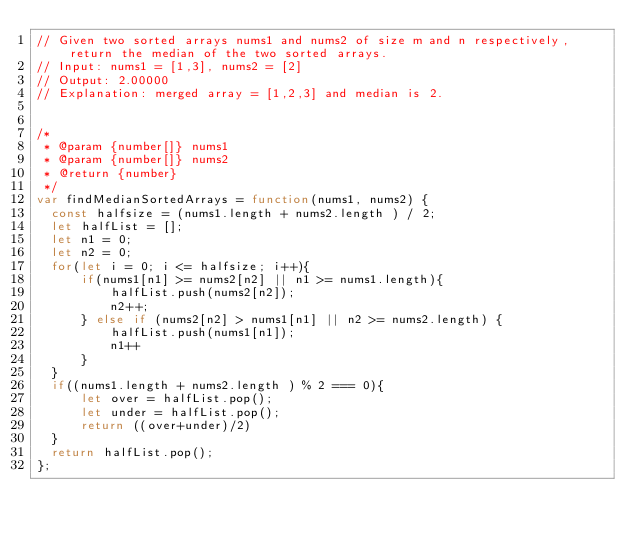<code> <loc_0><loc_0><loc_500><loc_500><_JavaScript_>// Given two sorted arrays nums1 and nums2 of size m and n respectively, return the median of the two sorted arrays.
// Input: nums1 = [1,3], nums2 = [2]
// Output: 2.00000
// Explanation: merged array = [1,2,3] and median is 2.


/*
 * @param {number[]} nums1
 * @param {number[]} nums2
 * @return {number}
 */
var findMedianSortedArrays = function(nums1, nums2) {
  const halfsize = (nums1.length + nums2.length ) / 2;
  let halfList = [];
  let n1 = 0;
  let n2 = 0;
  for(let i = 0; i <= halfsize; i++){
      if(nums1[n1] >= nums2[n2] || n1 >= nums1.length){
          halfList.push(nums2[n2]);
          n2++;
      } else if (nums2[n2] > nums1[n1] || n2 >= nums2.length) {
          halfList.push(nums1[n1]);
          n1++
      }
  }
  if((nums1.length + nums2.length ) % 2 === 0){
      let over = halfList.pop();
      let under = halfList.pop();
      return ((over+under)/2)
  }
  return halfList.pop();
};</code> 